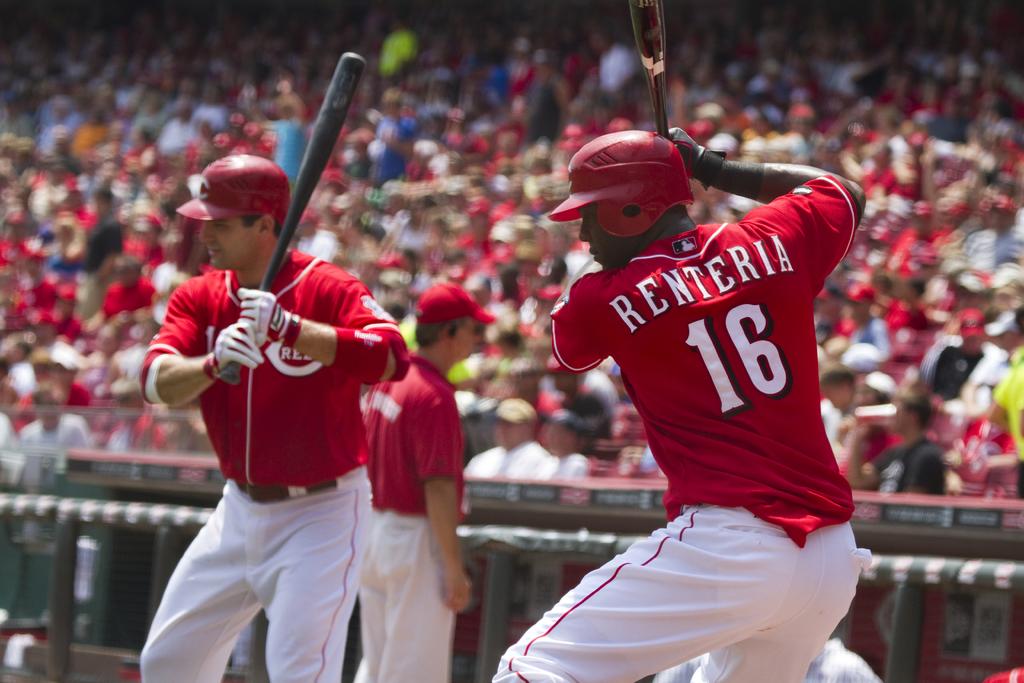What is the number on the batters back ?
Your answer should be compact. 16. What is the name of number 16?
Provide a short and direct response. Renteria. 